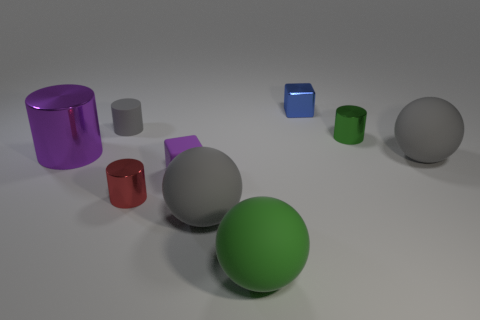There is a gray ball that is right of the metal cube; does it have the same size as the metal thing that is right of the blue block? The sizes of the gray ball right of the metal cube and the metal object right of the blue block appear to be different; the gray ball seems to be larger. 